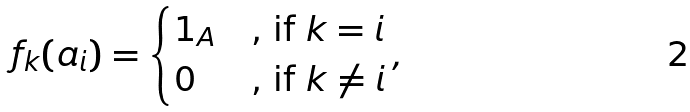<formula> <loc_0><loc_0><loc_500><loc_500>f _ { k } ( a _ { i } ) = \begin{cases} 1 _ { A } & \text {, if } k = i \\ 0 & \text {, if } k \neq i \end{cases} ,</formula> 